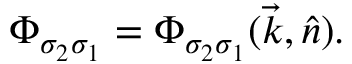Convert formula to latex. <formula><loc_0><loc_0><loc_500><loc_500>{ \mathit \Phi } _ { \sigma _ { 2 } \sigma _ { 1 } } = { \mathit \Phi } _ { \sigma _ { 2 } \sigma _ { 1 } } ( \vec { k } , \hat { n } ) .</formula> 